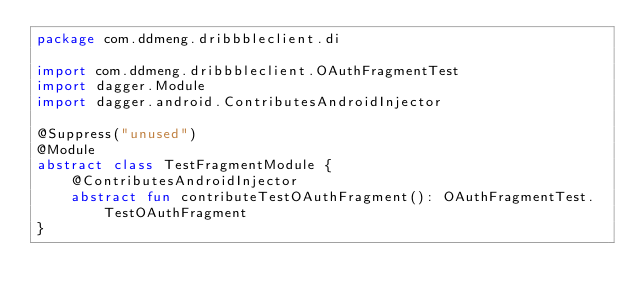<code> <loc_0><loc_0><loc_500><loc_500><_Kotlin_>package com.ddmeng.dribbbleclient.di

import com.ddmeng.dribbbleclient.OAuthFragmentTest
import dagger.Module
import dagger.android.ContributesAndroidInjector

@Suppress("unused")
@Module
abstract class TestFragmentModule {
    @ContributesAndroidInjector
    abstract fun contributeTestOAuthFragment(): OAuthFragmentTest.TestOAuthFragment
}
</code> 